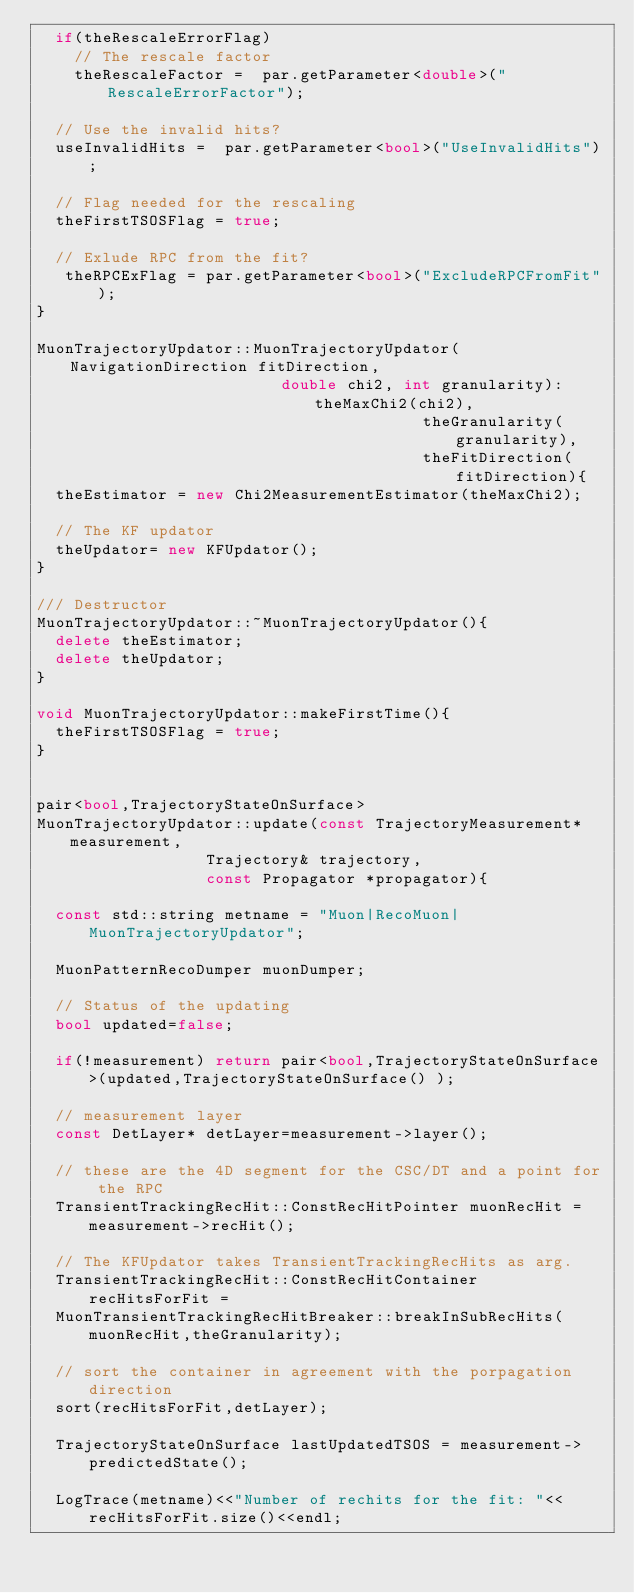<code> <loc_0><loc_0><loc_500><loc_500><_C++_>  if(theRescaleErrorFlag)
    // The rescale factor
    theRescaleFactor =  par.getParameter<double>("RescaleErrorFactor");
  
  // Use the invalid hits?
  useInvalidHits =  par.getParameter<bool>("UseInvalidHits");

  // Flag needed for the rescaling
  theFirstTSOSFlag = true;

  // Exlude RPC from the fit?
   theRPCExFlag = par.getParameter<bool>("ExcludeRPCFromFit");
}

MuonTrajectoryUpdator::MuonTrajectoryUpdator( NavigationDirection fitDirection,
					      double chi2, int granularity): theMaxChi2(chi2),
									     theGranularity(granularity),
									     theFitDirection(fitDirection){
  theEstimator = new Chi2MeasurementEstimator(theMaxChi2);
  
  // The KF updator
  theUpdator= new KFUpdator();
}

/// Destructor
MuonTrajectoryUpdator::~MuonTrajectoryUpdator(){
  delete theEstimator;
  delete theUpdator;
}

void MuonTrajectoryUpdator::makeFirstTime(){
  theFirstTSOSFlag = true;
}


pair<bool,TrajectoryStateOnSurface> 
MuonTrajectoryUpdator::update(const TrajectoryMeasurement* measurement,
			      Trajectory& trajectory,
			      const Propagator *propagator){
  
  const std::string metname = "Muon|RecoMuon|MuonTrajectoryUpdator";

  MuonPatternRecoDumper muonDumper;

  // Status of the updating
  bool updated=false;
  
  if(!measurement) return pair<bool,TrajectoryStateOnSurface>(updated,TrajectoryStateOnSurface() );

  // measurement layer
  const DetLayer* detLayer=measurement->layer();

  // these are the 4D segment for the CSC/DT and a point for the RPC 
  TransientTrackingRecHit::ConstRecHitPointer muonRecHit = measurement->recHit();
 
  // The KFUpdator takes TransientTrackingRecHits as arg.
  TransientTrackingRecHit::ConstRecHitContainer recHitsForFit =
  MuonTransientTrackingRecHitBreaker::breakInSubRecHits(muonRecHit,theGranularity);

  // sort the container in agreement with the porpagation direction
  sort(recHitsForFit,detLayer);
  
  TrajectoryStateOnSurface lastUpdatedTSOS = measurement->predictedState();
  
  LogTrace(metname)<<"Number of rechits for the fit: "<<recHitsForFit.size()<<endl;
 </code> 